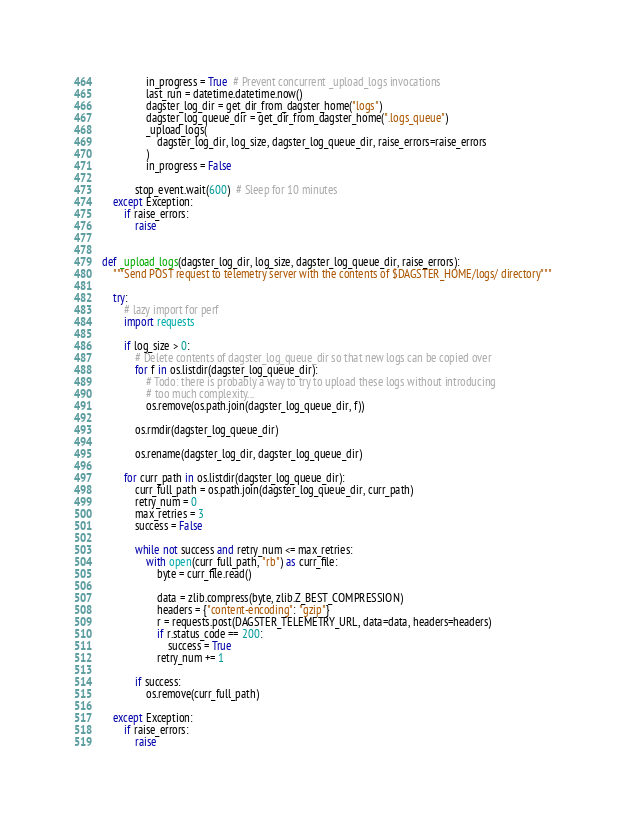<code> <loc_0><loc_0><loc_500><loc_500><_Python_>                in_progress = True  # Prevent concurrent _upload_logs invocations
                last_run = datetime.datetime.now()
                dagster_log_dir = get_dir_from_dagster_home("logs")
                dagster_log_queue_dir = get_dir_from_dagster_home(".logs_queue")
                _upload_logs(
                    dagster_log_dir, log_size, dagster_log_queue_dir, raise_errors=raise_errors
                )
                in_progress = False

            stop_event.wait(600)  # Sleep for 10 minutes
    except Exception:
        if raise_errors:
            raise


def _upload_logs(dagster_log_dir, log_size, dagster_log_queue_dir, raise_errors):
    """Send POST request to telemetry server with the contents of $DAGSTER_HOME/logs/ directory"""

    try:
        # lazy import for perf
        import requests

        if log_size > 0:
            # Delete contents of dagster_log_queue_dir so that new logs can be copied over
            for f in os.listdir(dagster_log_queue_dir):
                # Todo: there is probably a way to try to upload these logs without introducing
                # too much complexity...
                os.remove(os.path.join(dagster_log_queue_dir, f))

            os.rmdir(dagster_log_queue_dir)

            os.rename(dagster_log_dir, dagster_log_queue_dir)

        for curr_path in os.listdir(dagster_log_queue_dir):
            curr_full_path = os.path.join(dagster_log_queue_dir, curr_path)
            retry_num = 0
            max_retries = 3
            success = False

            while not success and retry_num <= max_retries:
                with open(curr_full_path, "rb") as curr_file:
                    byte = curr_file.read()

                    data = zlib.compress(byte, zlib.Z_BEST_COMPRESSION)
                    headers = {"content-encoding": "gzip"}
                    r = requests.post(DAGSTER_TELEMETRY_URL, data=data, headers=headers)
                    if r.status_code == 200:
                        success = True
                    retry_num += 1

            if success:
                os.remove(curr_full_path)

    except Exception:
        if raise_errors:
            raise
</code> 